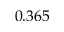Convert formula to latex. <formula><loc_0><loc_0><loc_500><loc_500>0 . 3 6 5</formula> 